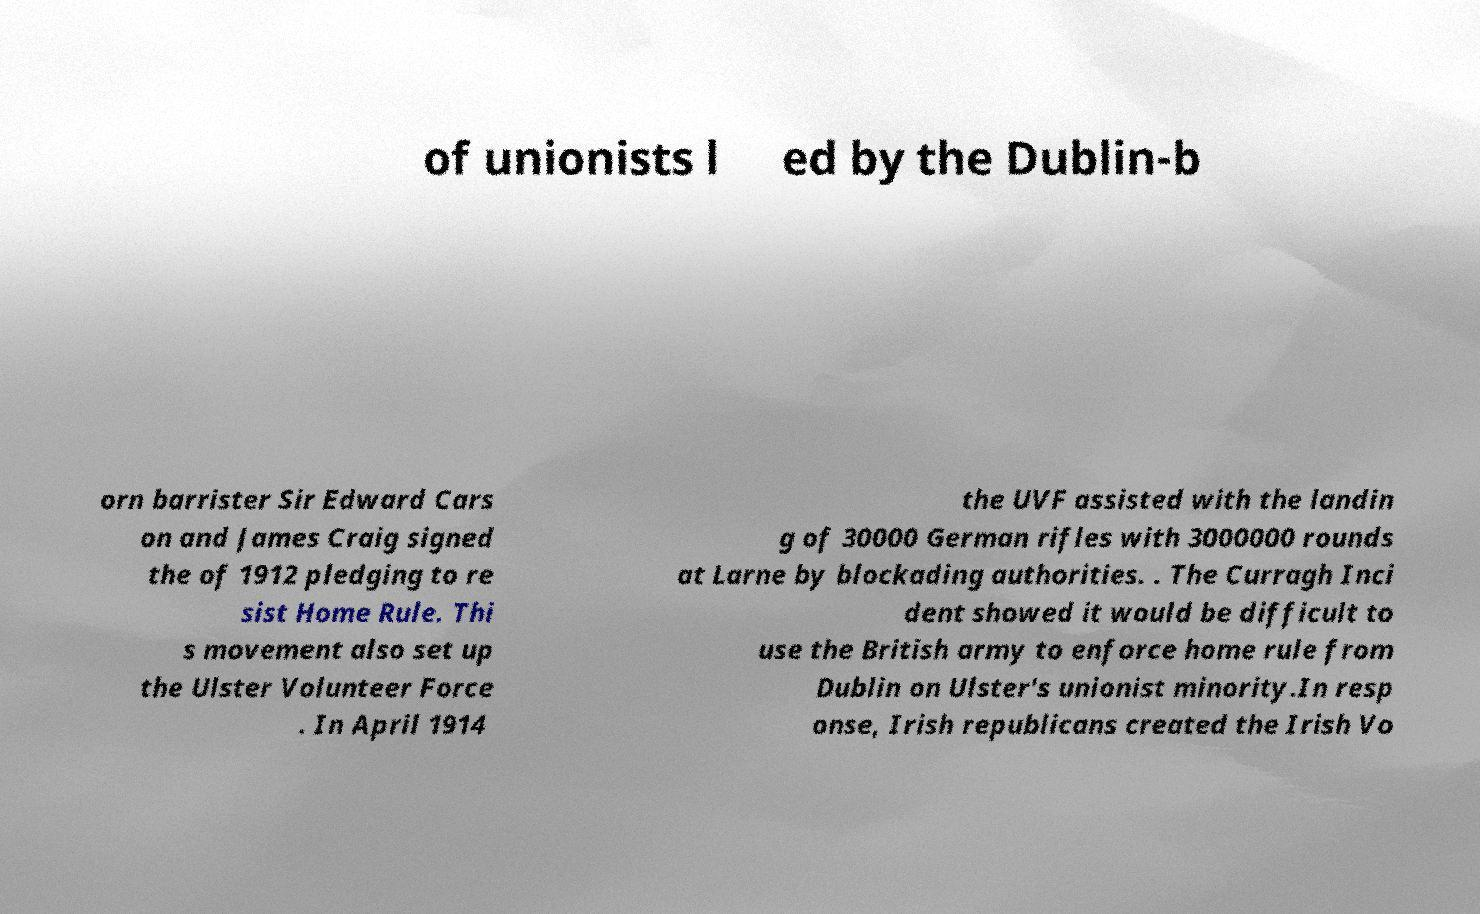Could you extract and type out the text from this image? of unionists l ed by the Dublin-b orn barrister Sir Edward Cars on and James Craig signed the of 1912 pledging to re sist Home Rule. Thi s movement also set up the Ulster Volunteer Force . In April 1914 the UVF assisted with the landin g of 30000 German rifles with 3000000 rounds at Larne by blockading authorities. . The Curragh Inci dent showed it would be difficult to use the British army to enforce home rule from Dublin on Ulster's unionist minority.In resp onse, Irish republicans created the Irish Vo 